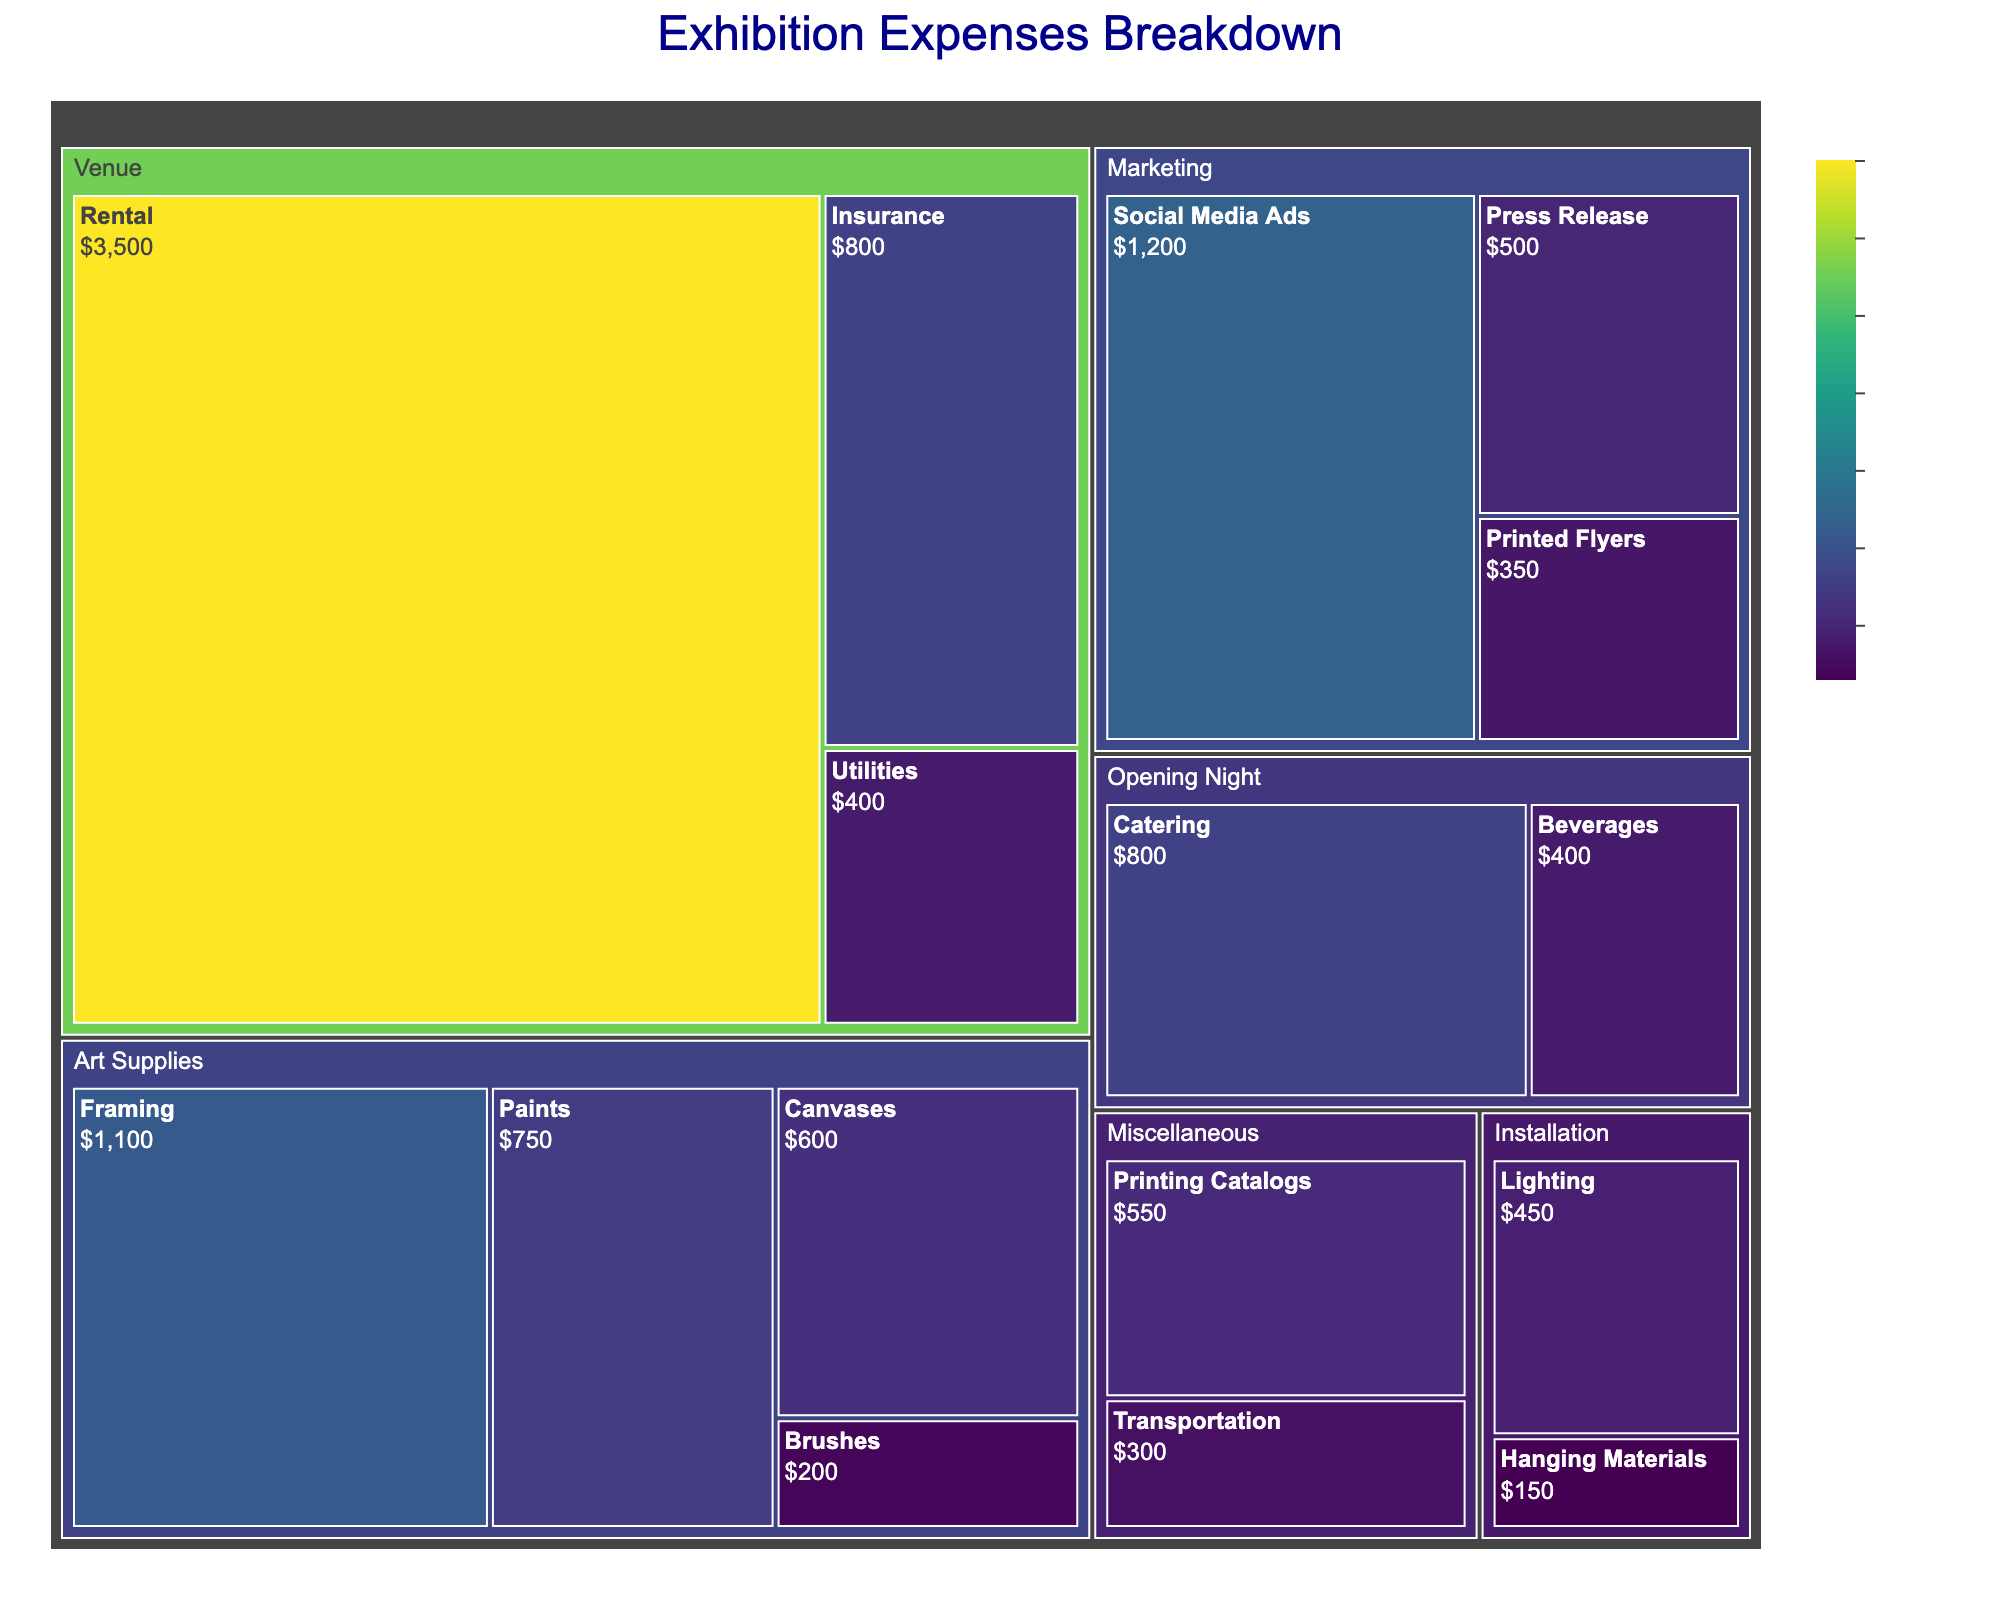Which category has the highest total expenses? By examining the treemap, the category with the largest area represents the category with the highest total expenses.
Answer: Venue What is the total amount spent on Marketing? Sum up the amounts spent on Social Media Ads, Printed Flyers, and Press Release from the Marketing category. $1200 + $350 + $500 = $2050
Answer: $2050 How much was spent on Art Supplies compared to Installation? Sum up the amounts for Art Supplies (Paints, Canvases, Brushes, Framing) and Installation (Lighting, Hanging Materials). Compare the two totals. $750 + $600 + $200 + $1100 = $2650 for Art Supplies, $450 + $150 = $600 for Installation.
Answer: Art Supplies Which subcategory within the Venue category has the highest expenses? Look at the subcategories Rental, Insurance, and Utilities within the Venue category. The subcategory with the largest area is Rental.
Answer: Rental What percentage of the total expenses was spent on the Opening Night? To find this, add the amounts for Catering and Beverages, then divide by the total expenses and multiply by 100. ($800 + $400) / $11650 * 100 = 10.3%
Answer: 10.3% What is the least amount spent in any subcategory? Looking for the smallest area in the treemap, the smallest subcategory by expenses is Hanging Materials with $150.
Answer: $150 How does the amount spent on Catering compare to the amount spent on Framing? Compare the amounts directly from the treemap. $800 (Catering) vs $1100 (Framing). Catering is less.
Answer: Framing Which two subcategories within Marketing have the most similar expenses? Comparing Social Media Ads, Printed Flyers, and Press Release. Printed Flyers ($350) and Press Release ($500) are the closest.
Answer: Printed Flyers and Press Release What is the combined expense of the two smallest subcategories? The two smallest subcategories are Hanging Materials ($150) and Transportation ($300). Summing them gives $150 + $300 = $450.
Answer: $450 